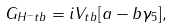<formula> <loc_0><loc_0><loc_500><loc_500>G _ { H ^ { - } t b } = i V _ { t b } [ a - b \gamma _ { 5 } ] ,</formula> 